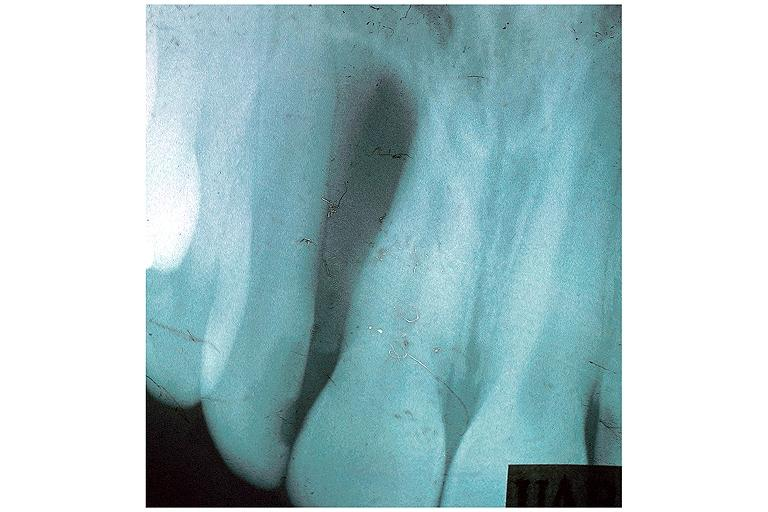does von show globulomaxillary cyst?
Answer the question using a single word or phrase. No 